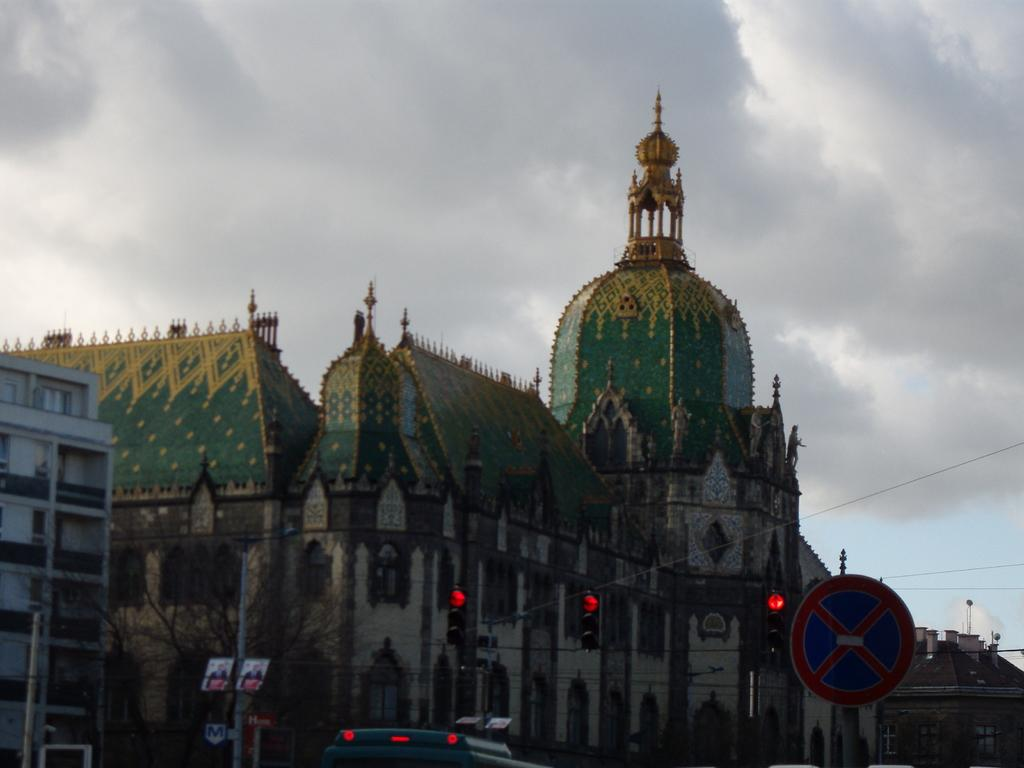What is the main object in the image? There is a sign board pole in the image. What else can be seen in the image? There is a vehicle, poles, a bare tree, buildings, windows, and clouds in the sky in the background of the image. Can you describe the vehicle in the image? The provided facts do not give specific details about the vehicle, so we cannot describe it further. What type of buildings are visible in the background of the image? The provided facts do not give specific details about the buildings, so we cannot describe them further. What grade of cherry is used to make the sign board pole in the image? There is no mention of cherries or a sign board pole made of cherry in the image. The sign board pole is likely made of metal or another material. What type of spoon is used to serve the clouds in the image? There are no spoons or clouds being served in the image. The clouds are simply visible in the sky in the background of the image. 